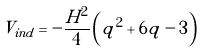Convert formula to latex. <formula><loc_0><loc_0><loc_500><loc_500>V _ { i n d } = - \frac { H ^ { 2 } } { 4 } \left ( q ^ { 2 } + 6 q - 3 \right )</formula> 